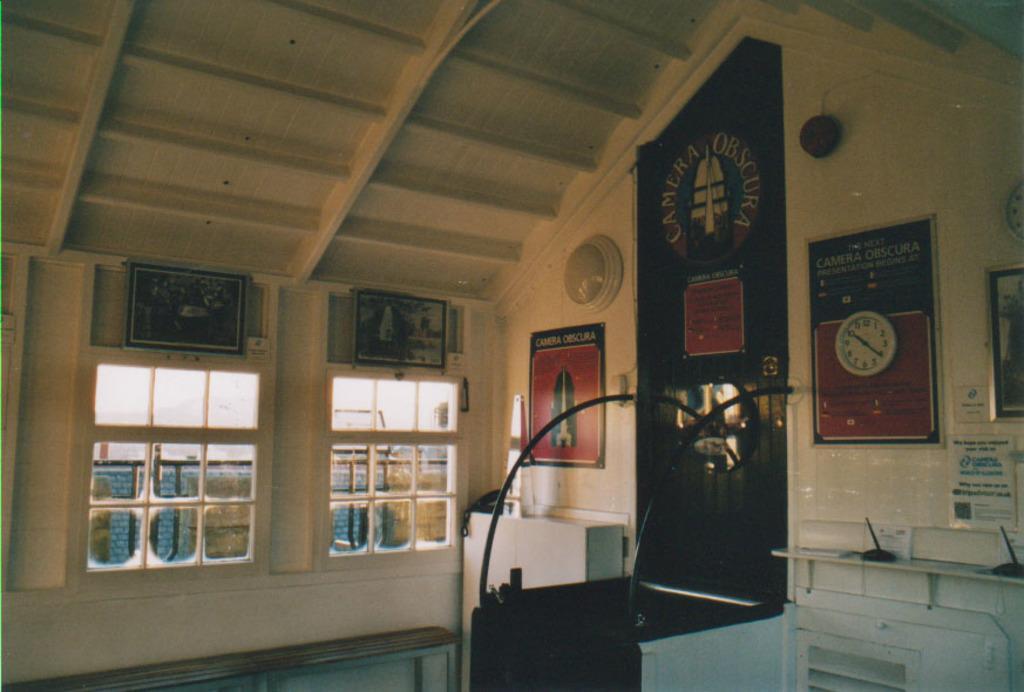Please provide a concise description of this image. In a room there are many frames attached to the wall and there are two windows. Beside the windows there is a telephone and in the background there is a wall. 